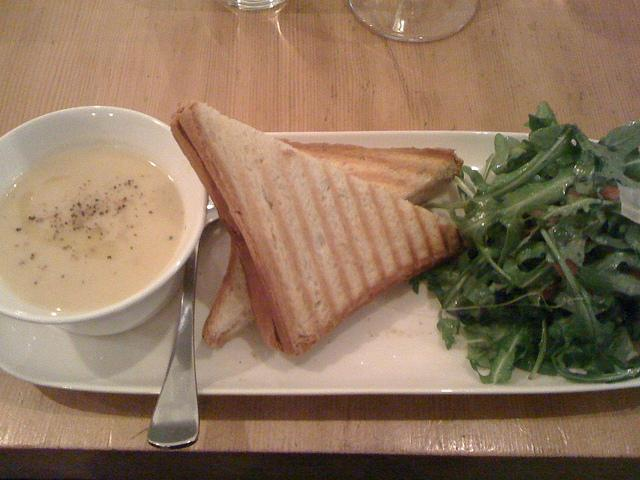Which of the objects on the plate is inedible? fork 